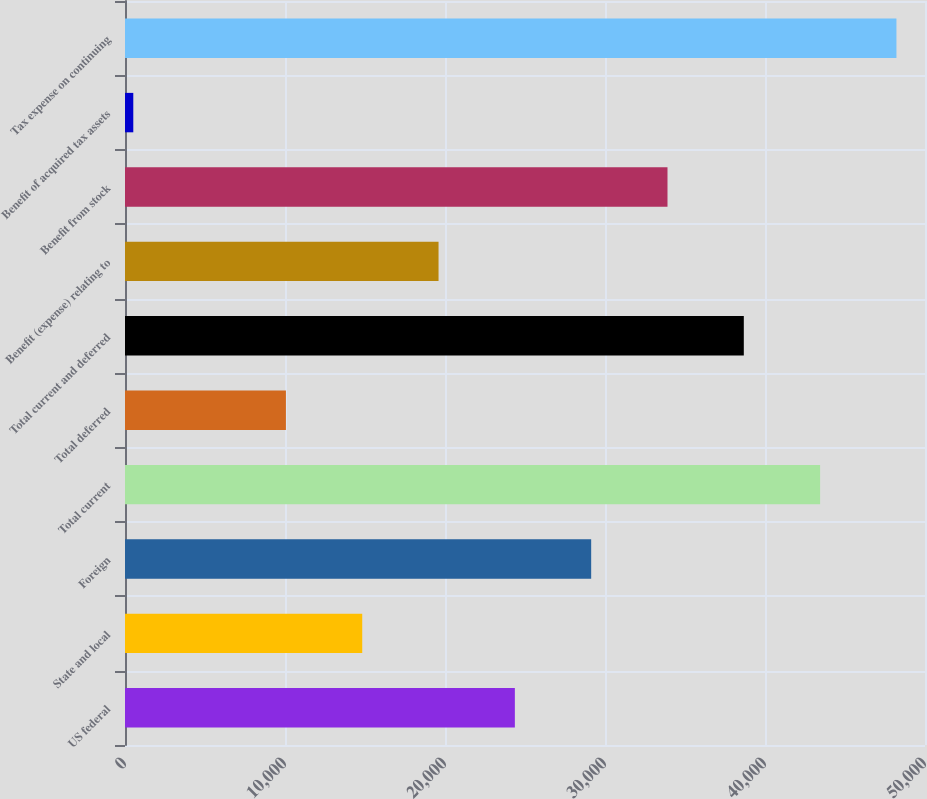Convert chart. <chart><loc_0><loc_0><loc_500><loc_500><bar_chart><fcel>US federal<fcel>State and local<fcel>Foreign<fcel>Total current<fcel>Total deferred<fcel>Total current and deferred<fcel>Benefit (expense) relating to<fcel>Benefit from stock<fcel>Benefit of acquired tax assets<fcel>Tax expense on continuing<nl><fcel>24366.5<fcel>14827.1<fcel>29136.2<fcel>43445.3<fcel>10057.4<fcel>38675.6<fcel>19596.8<fcel>33905.9<fcel>518<fcel>48215<nl></chart> 